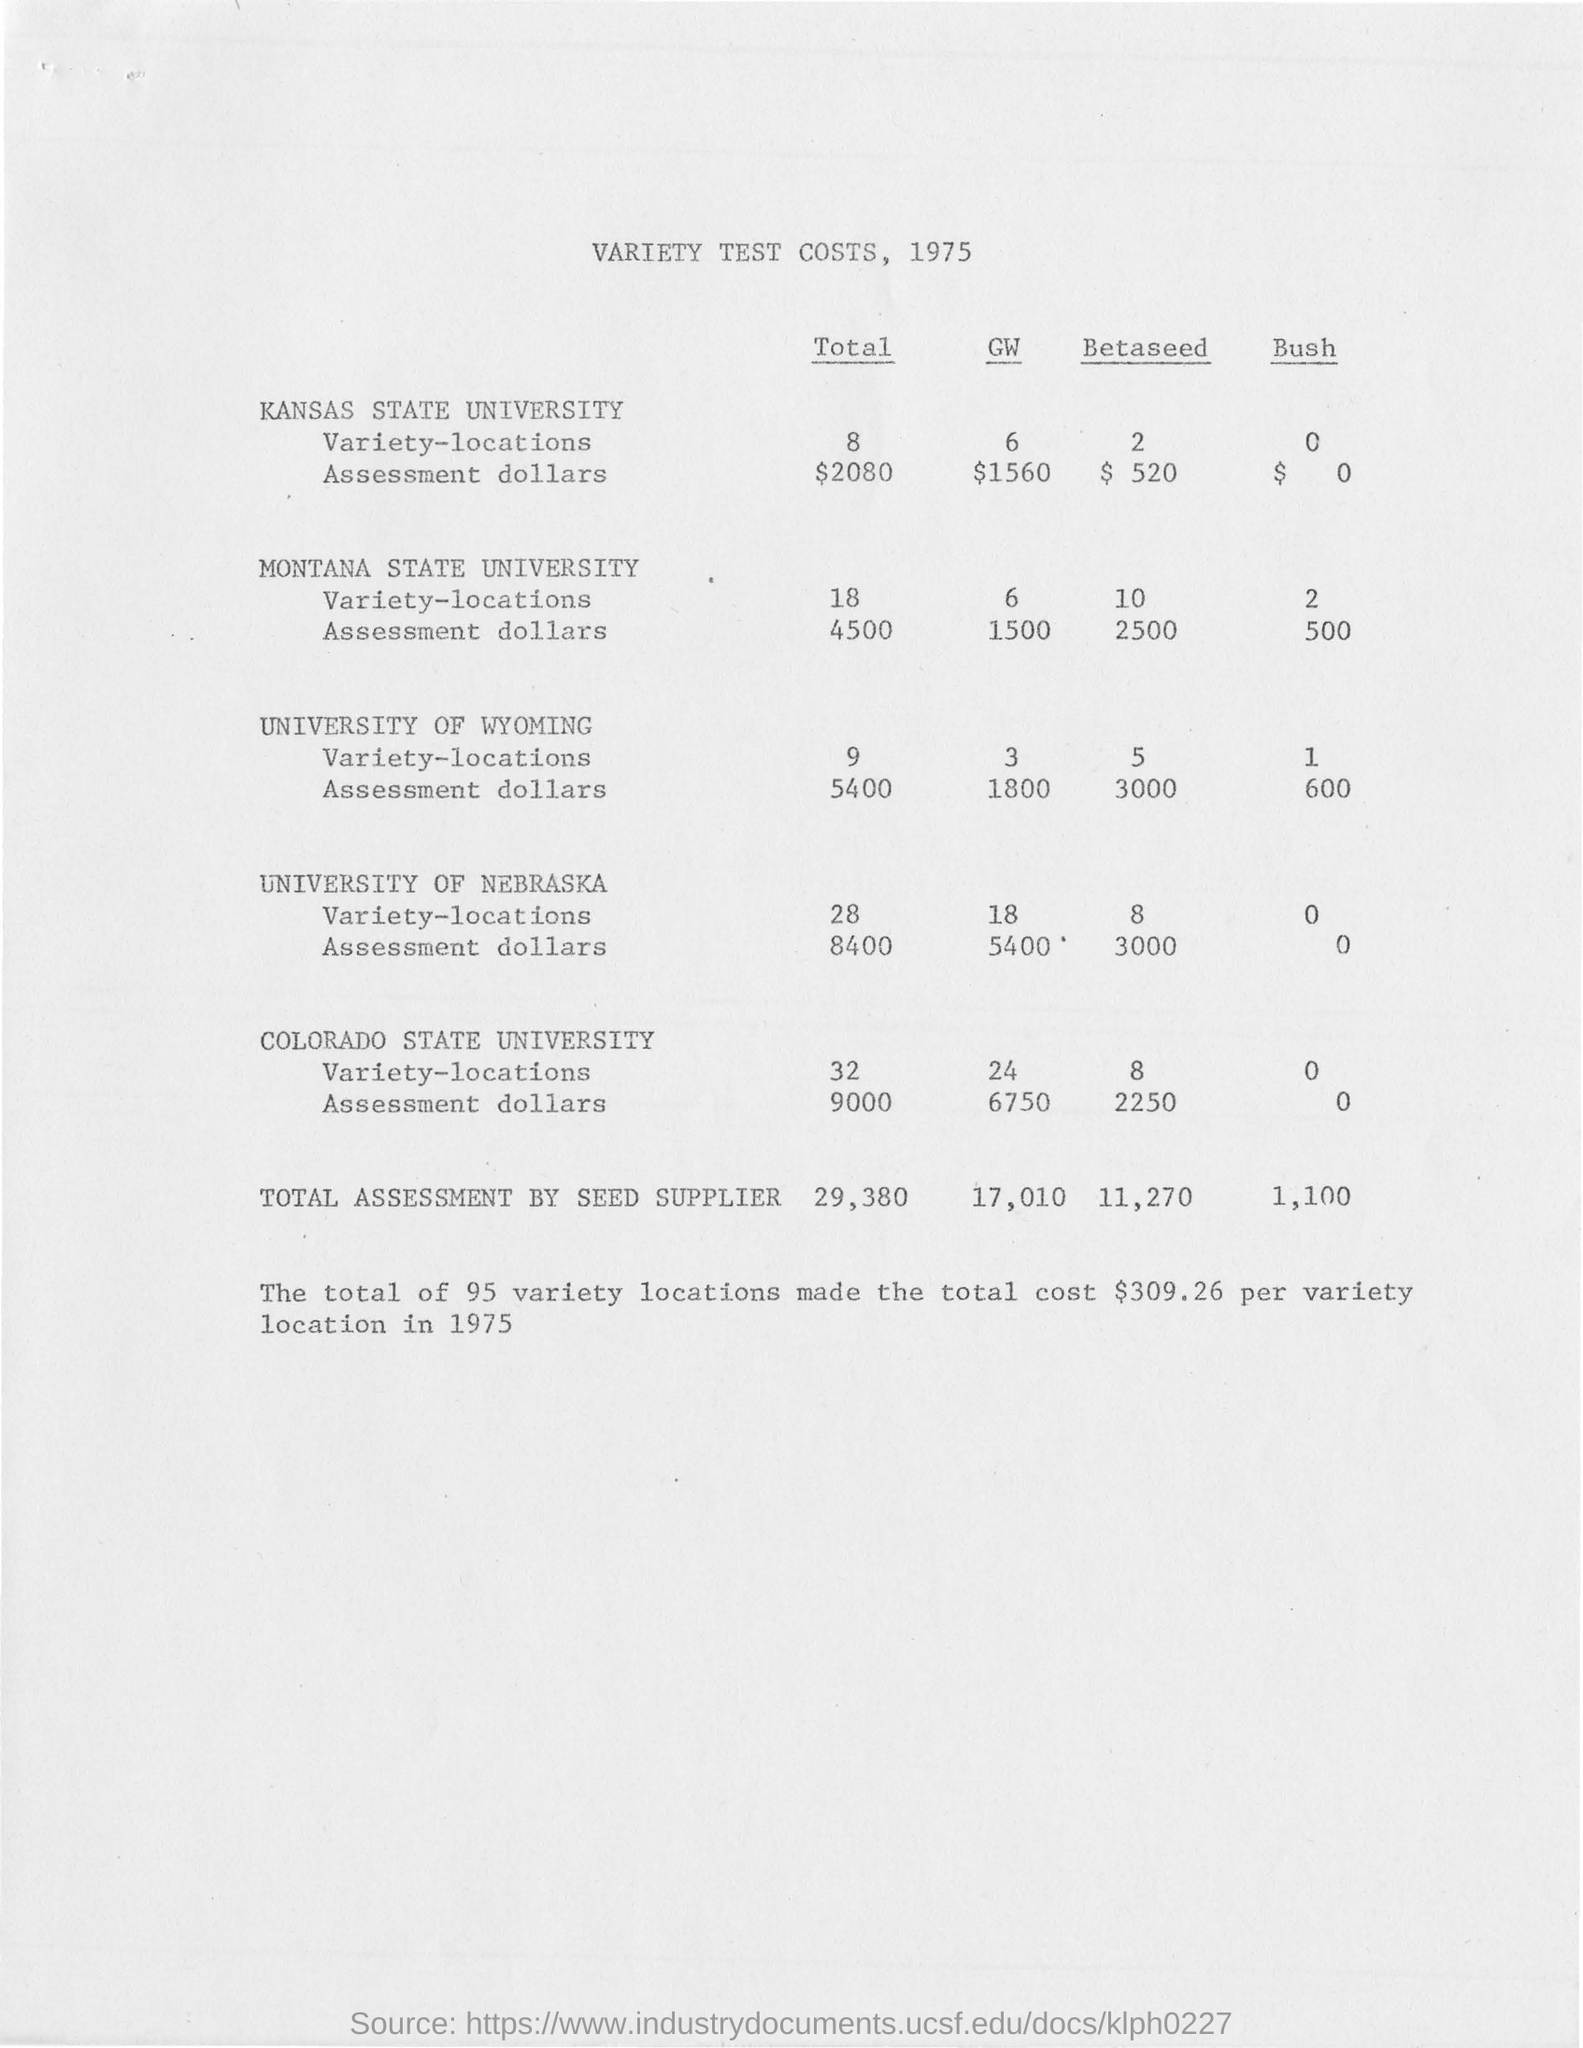Specify some key components in this picture. The year of this document is 1975. The total assessment amount by seed supplier is 29,380. The total number of variety locations is 95. The total cost per variety location in 1975 was 309.26. There are 8 different variety locations for Kansas State University. 